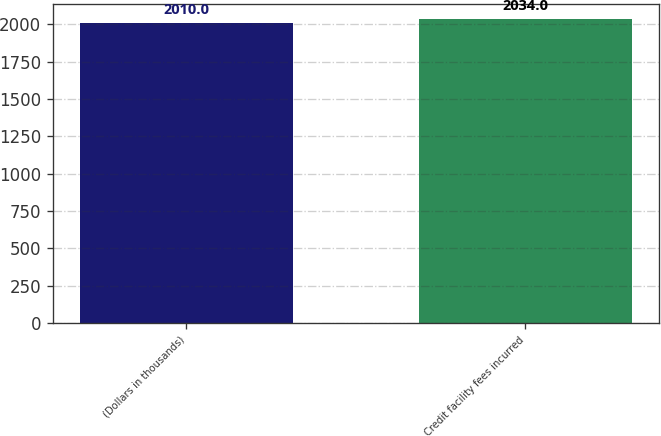<chart> <loc_0><loc_0><loc_500><loc_500><bar_chart><fcel>(Dollars in thousands)<fcel>Credit facility fees incurred<nl><fcel>2010<fcel>2034<nl></chart> 